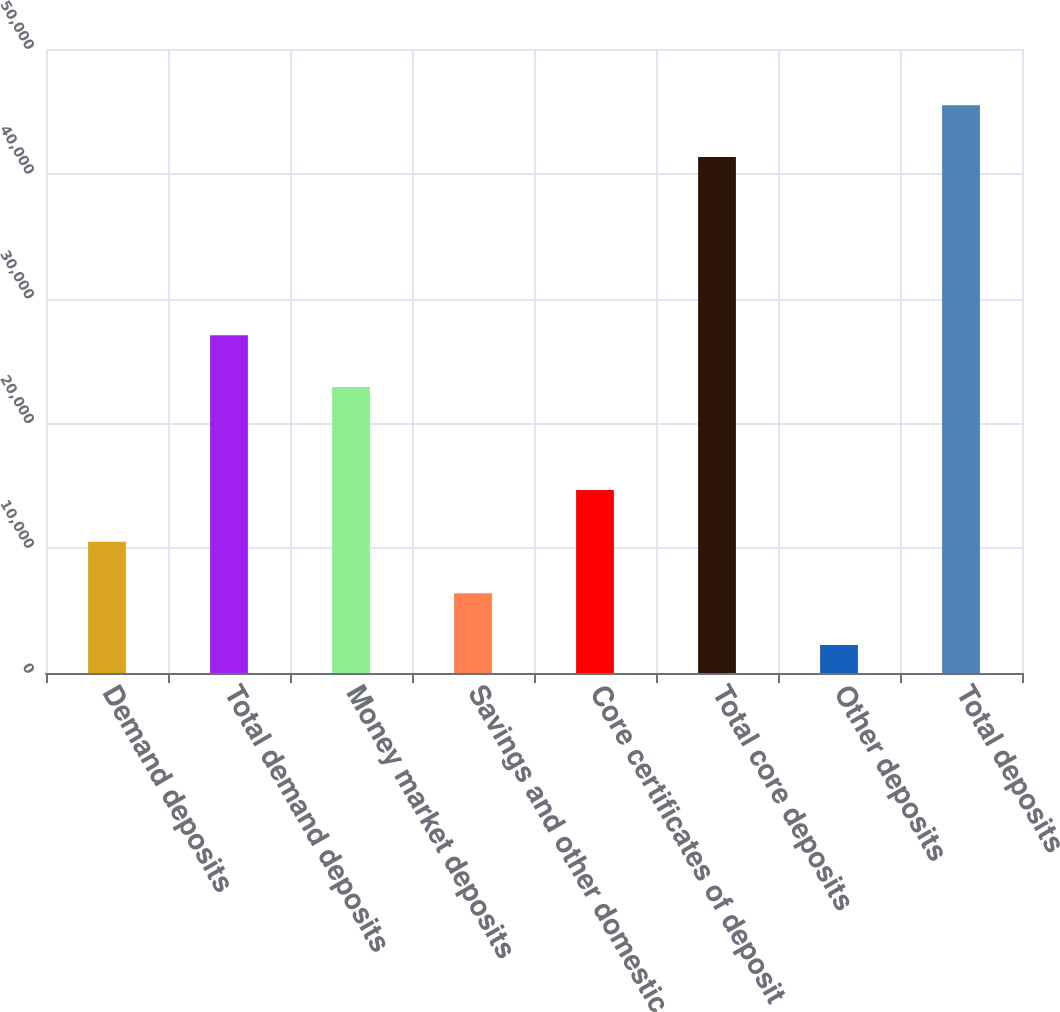Convert chart to OTSL. <chart><loc_0><loc_0><loc_500><loc_500><bar_chart><fcel>Demand deposits<fcel>Total demand deposits<fcel>Money market deposits<fcel>Savings and other domestic<fcel>Core certificates of deposit<fcel>Total core deposits<fcel>Other deposits<fcel>Total deposits<nl><fcel>10520<fcel>27062<fcel>22926.5<fcel>6384.5<fcel>14655.5<fcel>41355<fcel>2249<fcel>45490.5<nl></chart> 